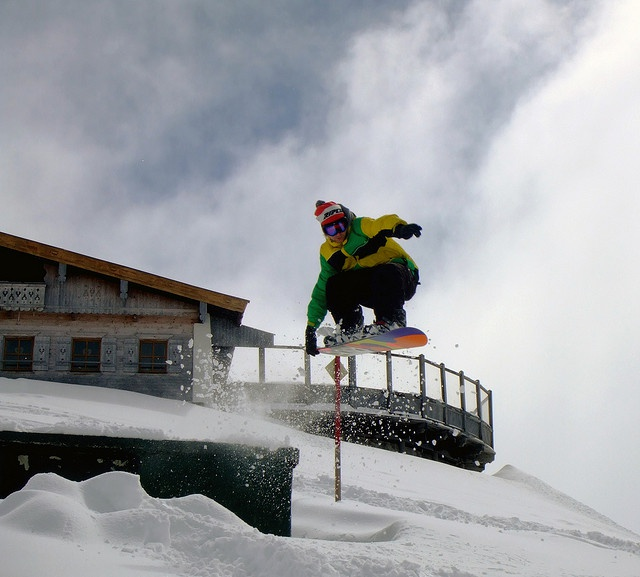Describe the objects in this image and their specific colors. I can see people in gray, black, lightgray, olive, and darkgreen tones and snowboard in gray, darkgray, and olive tones in this image. 